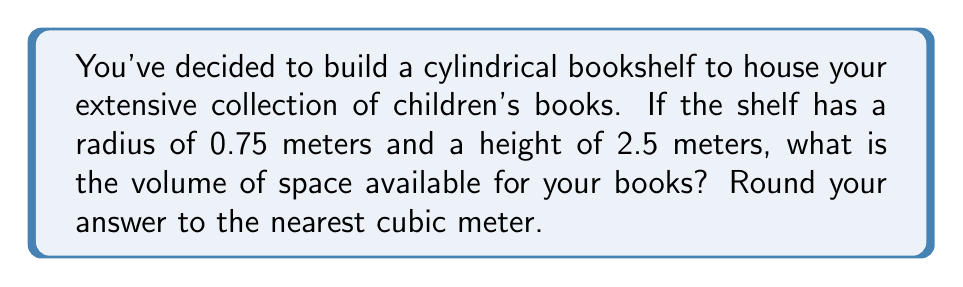Help me with this question. To calculate the volume of a cylindrical bookshelf, we need to use the formula for the volume of a cylinder:

$$V = \pi r^2 h$$

Where:
$V$ = volume
$r$ = radius of the base
$h$ = height of the cylinder

Given:
$r = 0.75$ meters
$h = 2.5$ meters

Let's substitute these values into the formula:

$$V = \pi (0.75\text{ m})^2 (2.5\text{ m})$$

Step 1: Calculate $r^2$
$$(0.75\text{ m})^2 = 0.5625\text{ m}^2$$

Step 2: Multiply by $\pi$ and $h$
$$V = \pi (0.5625\text{ m}^2) (2.5\text{ m})$$
$$V = 4.4178\text{ m}^3$$

Step 3: Round to the nearest cubic meter
$$V \approx 4\text{ m}^3$$

Therefore, the volume of space available for your books is approximately 4 cubic meters.
Answer: $4\text{ m}^3$ 